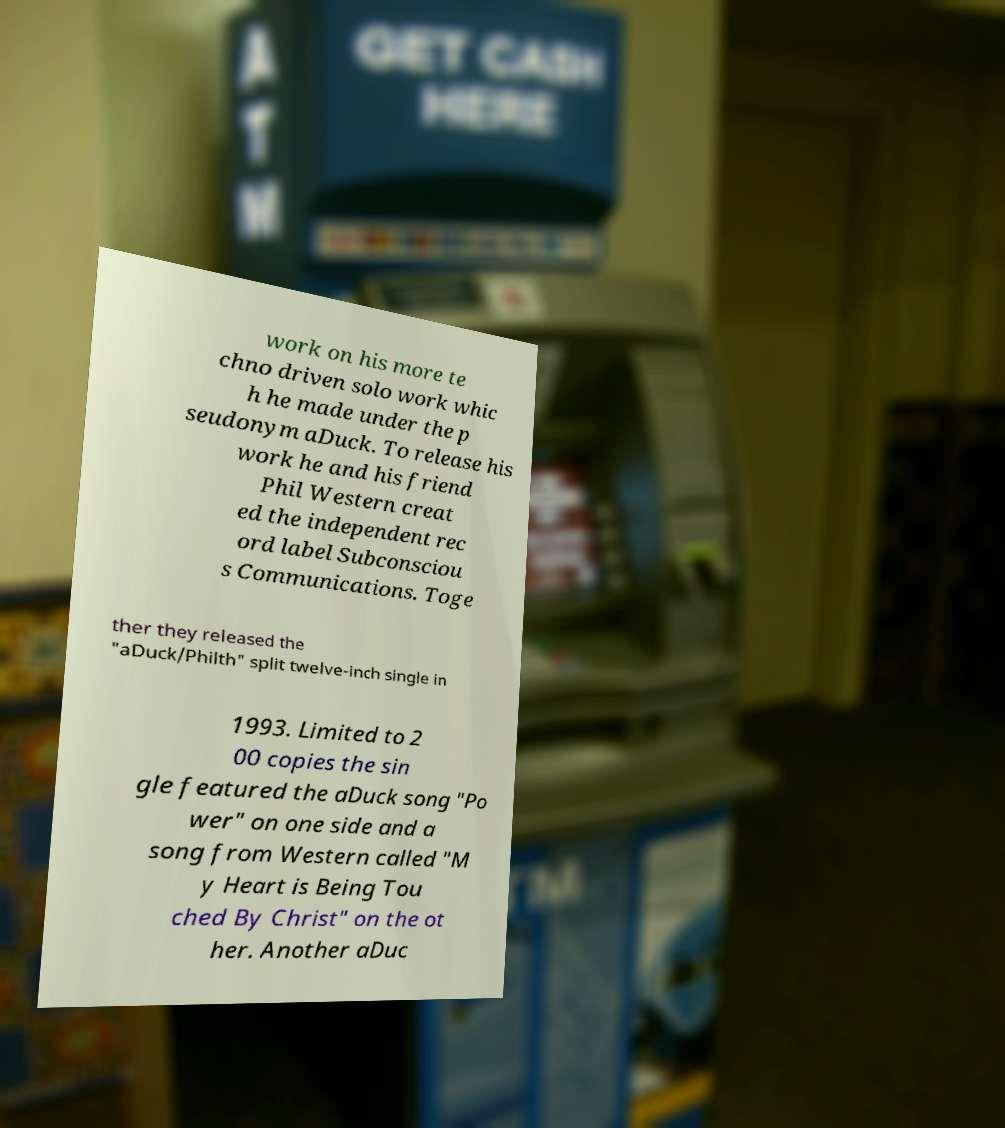Please identify and transcribe the text found in this image. work on his more te chno driven solo work whic h he made under the p seudonym aDuck. To release his work he and his friend Phil Western creat ed the independent rec ord label Subconsciou s Communications. Toge ther they released the "aDuck/Philth" split twelve-inch single in 1993. Limited to 2 00 copies the sin gle featured the aDuck song "Po wer" on one side and a song from Western called "M y Heart is Being Tou ched By Christ" on the ot her. Another aDuc 